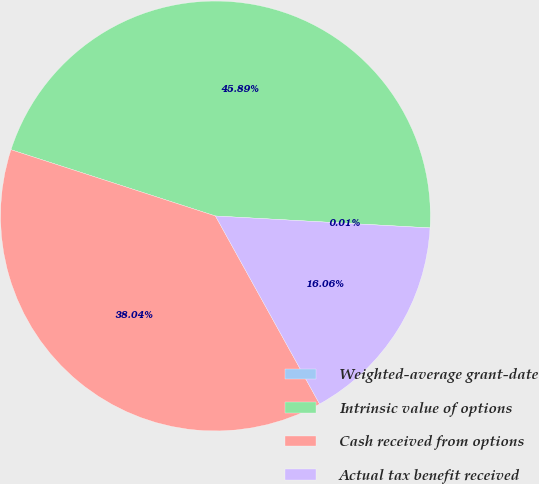Convert chart to OTSL. <chart><loc_0><loc_0><loc_500><loc_500><pie_chart><fcel>Weighted-average grant-date<fcel>Intrinsic value of options<fcel>Cash received from options<fcel>Actual tax benefit received<nl><fcel>0.01%<fcel>45.89%<fcel>38.04%<fcel>16.06%<nl></chart> 